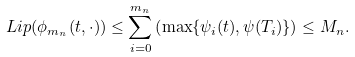Convert formula to latex. <formula><loc_0><loc_0><loc_500><loc_500>L i p ( \phi _ { m _ { n } } ( t , \cdot ) ) \leq \sum _ { i = 0 } ^ { m _ { n } } \left ( \max \{ \psi _ { i } ( t ) , \psi ( T _ { i } ) \} \right ) \leq M _ { n } .</formula> 